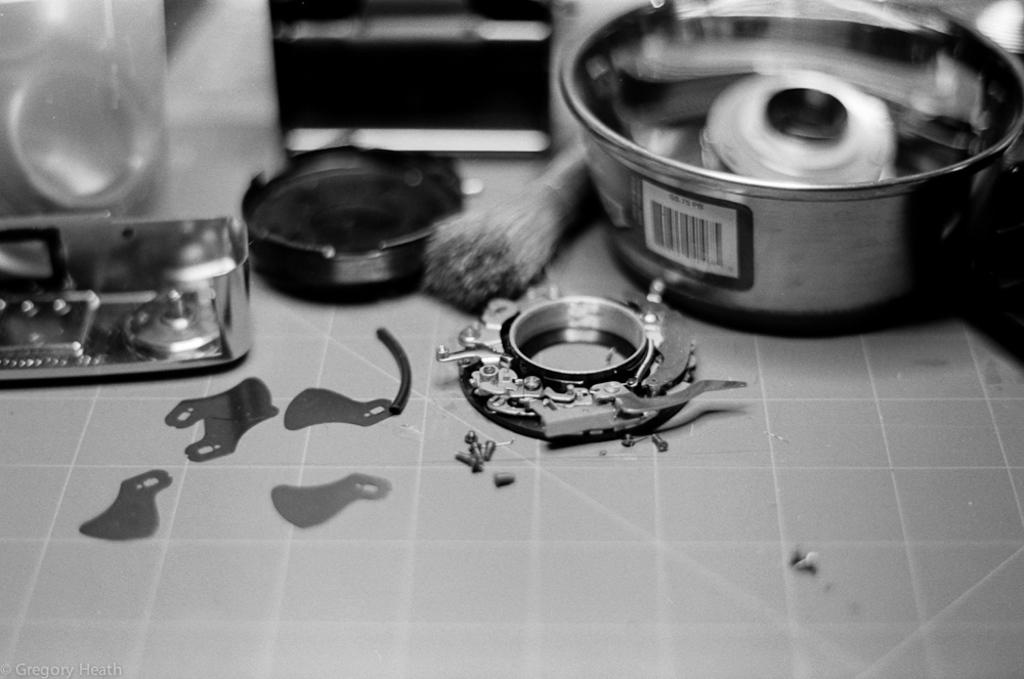What is located at the bottom of the image? There is a tile at the bottom of the image. What can be seen in the bowl in the image? There is no information about what is in the bowl, only that there is a bar code on it. What object is present in the image that is commonly used for cleaning or grooming? There is a brush in the image. What type of text is present at the bottom left of the image? There is text at the bottom left of the image, but the specific content is not mentioned. How many times does the dime jump in the image? There is no dime present in the image, so it cannot jump. What type of grip does the brush have in the image? The provided facts do not mention the type of grip the brush has, so we cannot answer this question. 